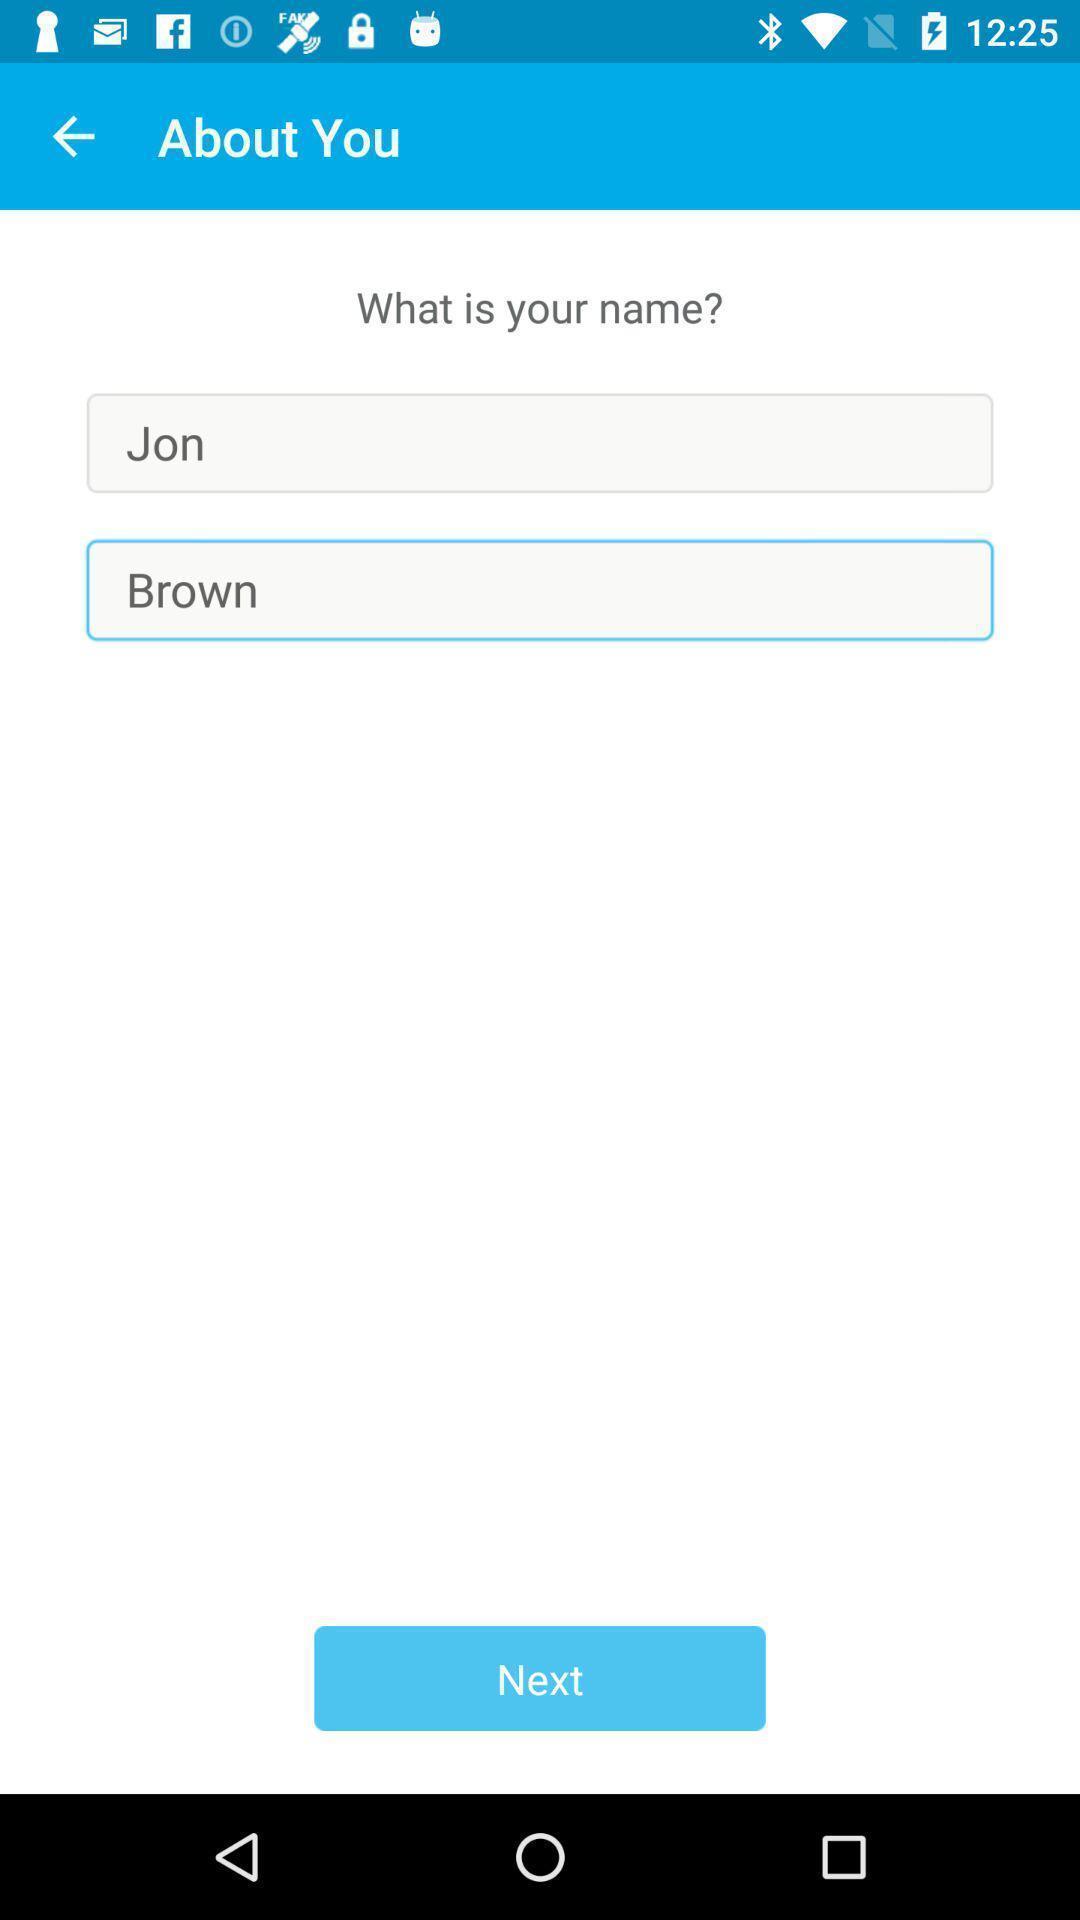Describe the visual elements of this screenshot. Screen page asking to fill my name. 